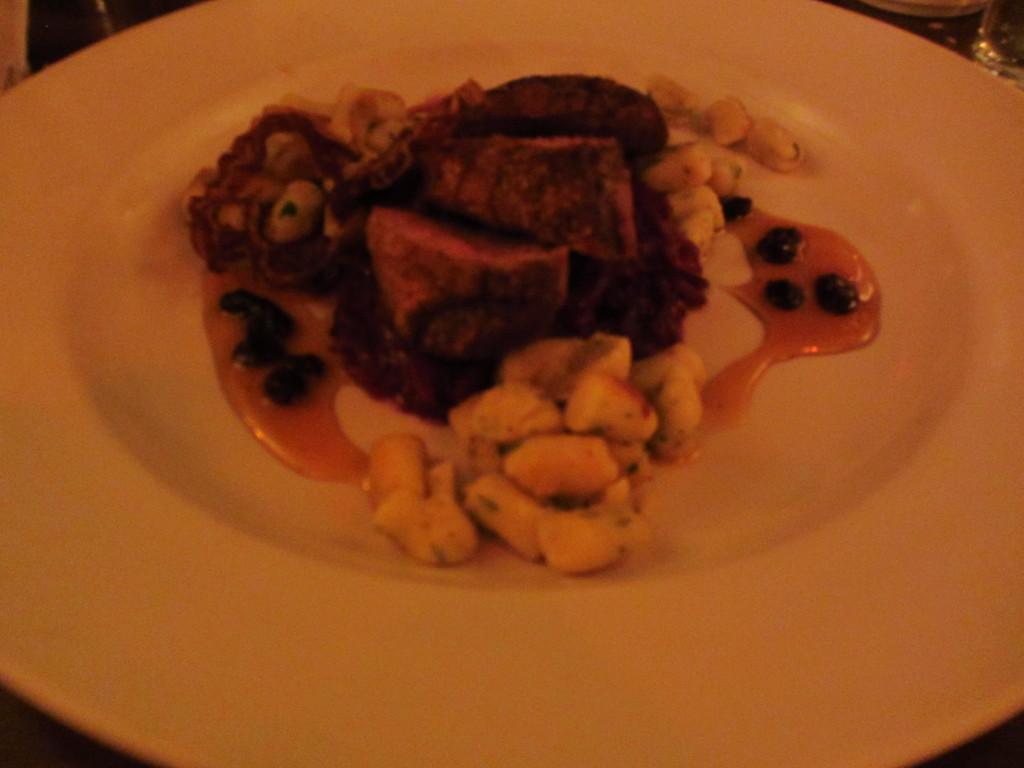Can you describe this image briefly? In this picture there is a food on the plate and in the top right there are glasses. 